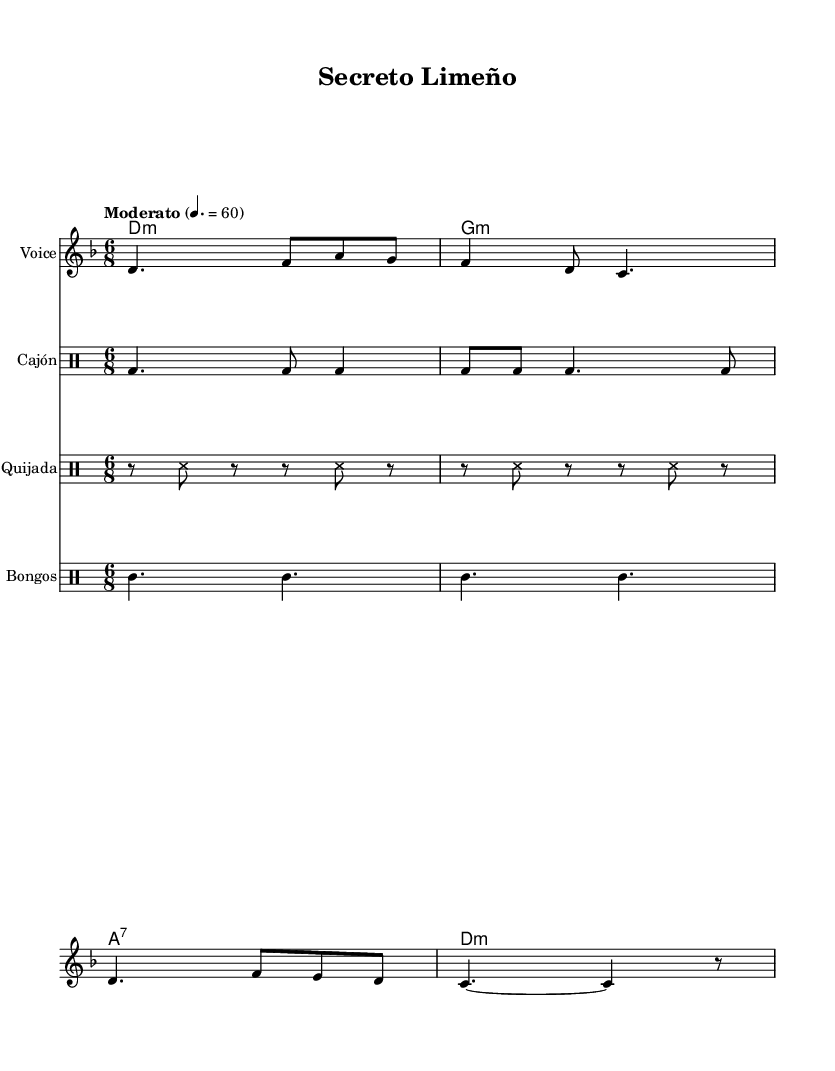What is the key signature of this music? The key signature is D minor, which has one flat. This can be identified by looking at the key signature marking at the beginning of the score.
Answer: D minor What is the time signature of this piece? The time signature is 6/8, indicated right after the key signature. This means there are six eighth notes per measure, giving it a lively, dance-like feel typical of Afro-Peruvian rhythms.
Answer: 6/8 What is the tempo marking for this music? The tempo marking is "Moderato", set at a tempo of 60 quarter notes per minute. This can be found at the beginning of the score, specifying how fast the piece should be played.
Answer: Moderato How many measures are there in the melody? There are four measures in the melody, which can be determined by counting the measures in the melody section of the sheet music.
Answer: 4 What type of drum is notated alongside the melody? The cajón is one of the drums notated, indicated under the melody section in the drum staff, and is a traditional Peruvian drum that adds a unique rhythm to the piece.
Answer: Cajón What rhythmic pattern does the quijada play? The quijada plays a distinctive alternating pattern of slaps and rests, indicated in the drum notation and typical of Afro-Peruvian music, which creates a lively and syncopated sound.
Answer: Alternating pattern What harmony is used in the first measure? The harmony in the first measure is D minor, as indicated in the chord section above the melody which shows the harmonic foundation of the piece.
Answer: D minor 